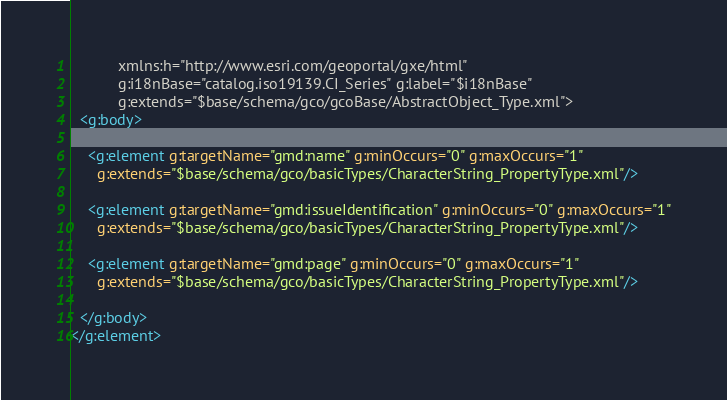<code> <loc_0><loc_0><loc_500><loc_500><_XML_>           xmlns:h="http://www.esri.com/geoportal/gxe/html"
           g:i18nBase="catalog.iso19139.CI_Series" g:label="$i18nBase"
           g:extends="$base/schema/gco/gcoBase/AbstractObject_Type.xml">
  <g:body>
  
    <g:element g:targetName="gmd:name" g:minOccurs="0" g:maxOccurs="1"
      g:extends="$base/schema/gco/basicTypes/CharacterString_PropertyType.xml"/>
    
    <g:element g:targetName="gmd:issueIdentification" g:minOccurs="0" g:maxOccurs="1"
      g:extends="$base/schema/gco/basicTypes/CharacterString_PropertyType.xml"/>
    
    <g:element g:targetName="gmd:page" g:minOccurs="0" g:maxOccurs="1"
      g:extends="$base/schema/gco/basicTypes/CharacterString_PropertyType.xml"/>
    
  </g:body>
</g:element></code> 